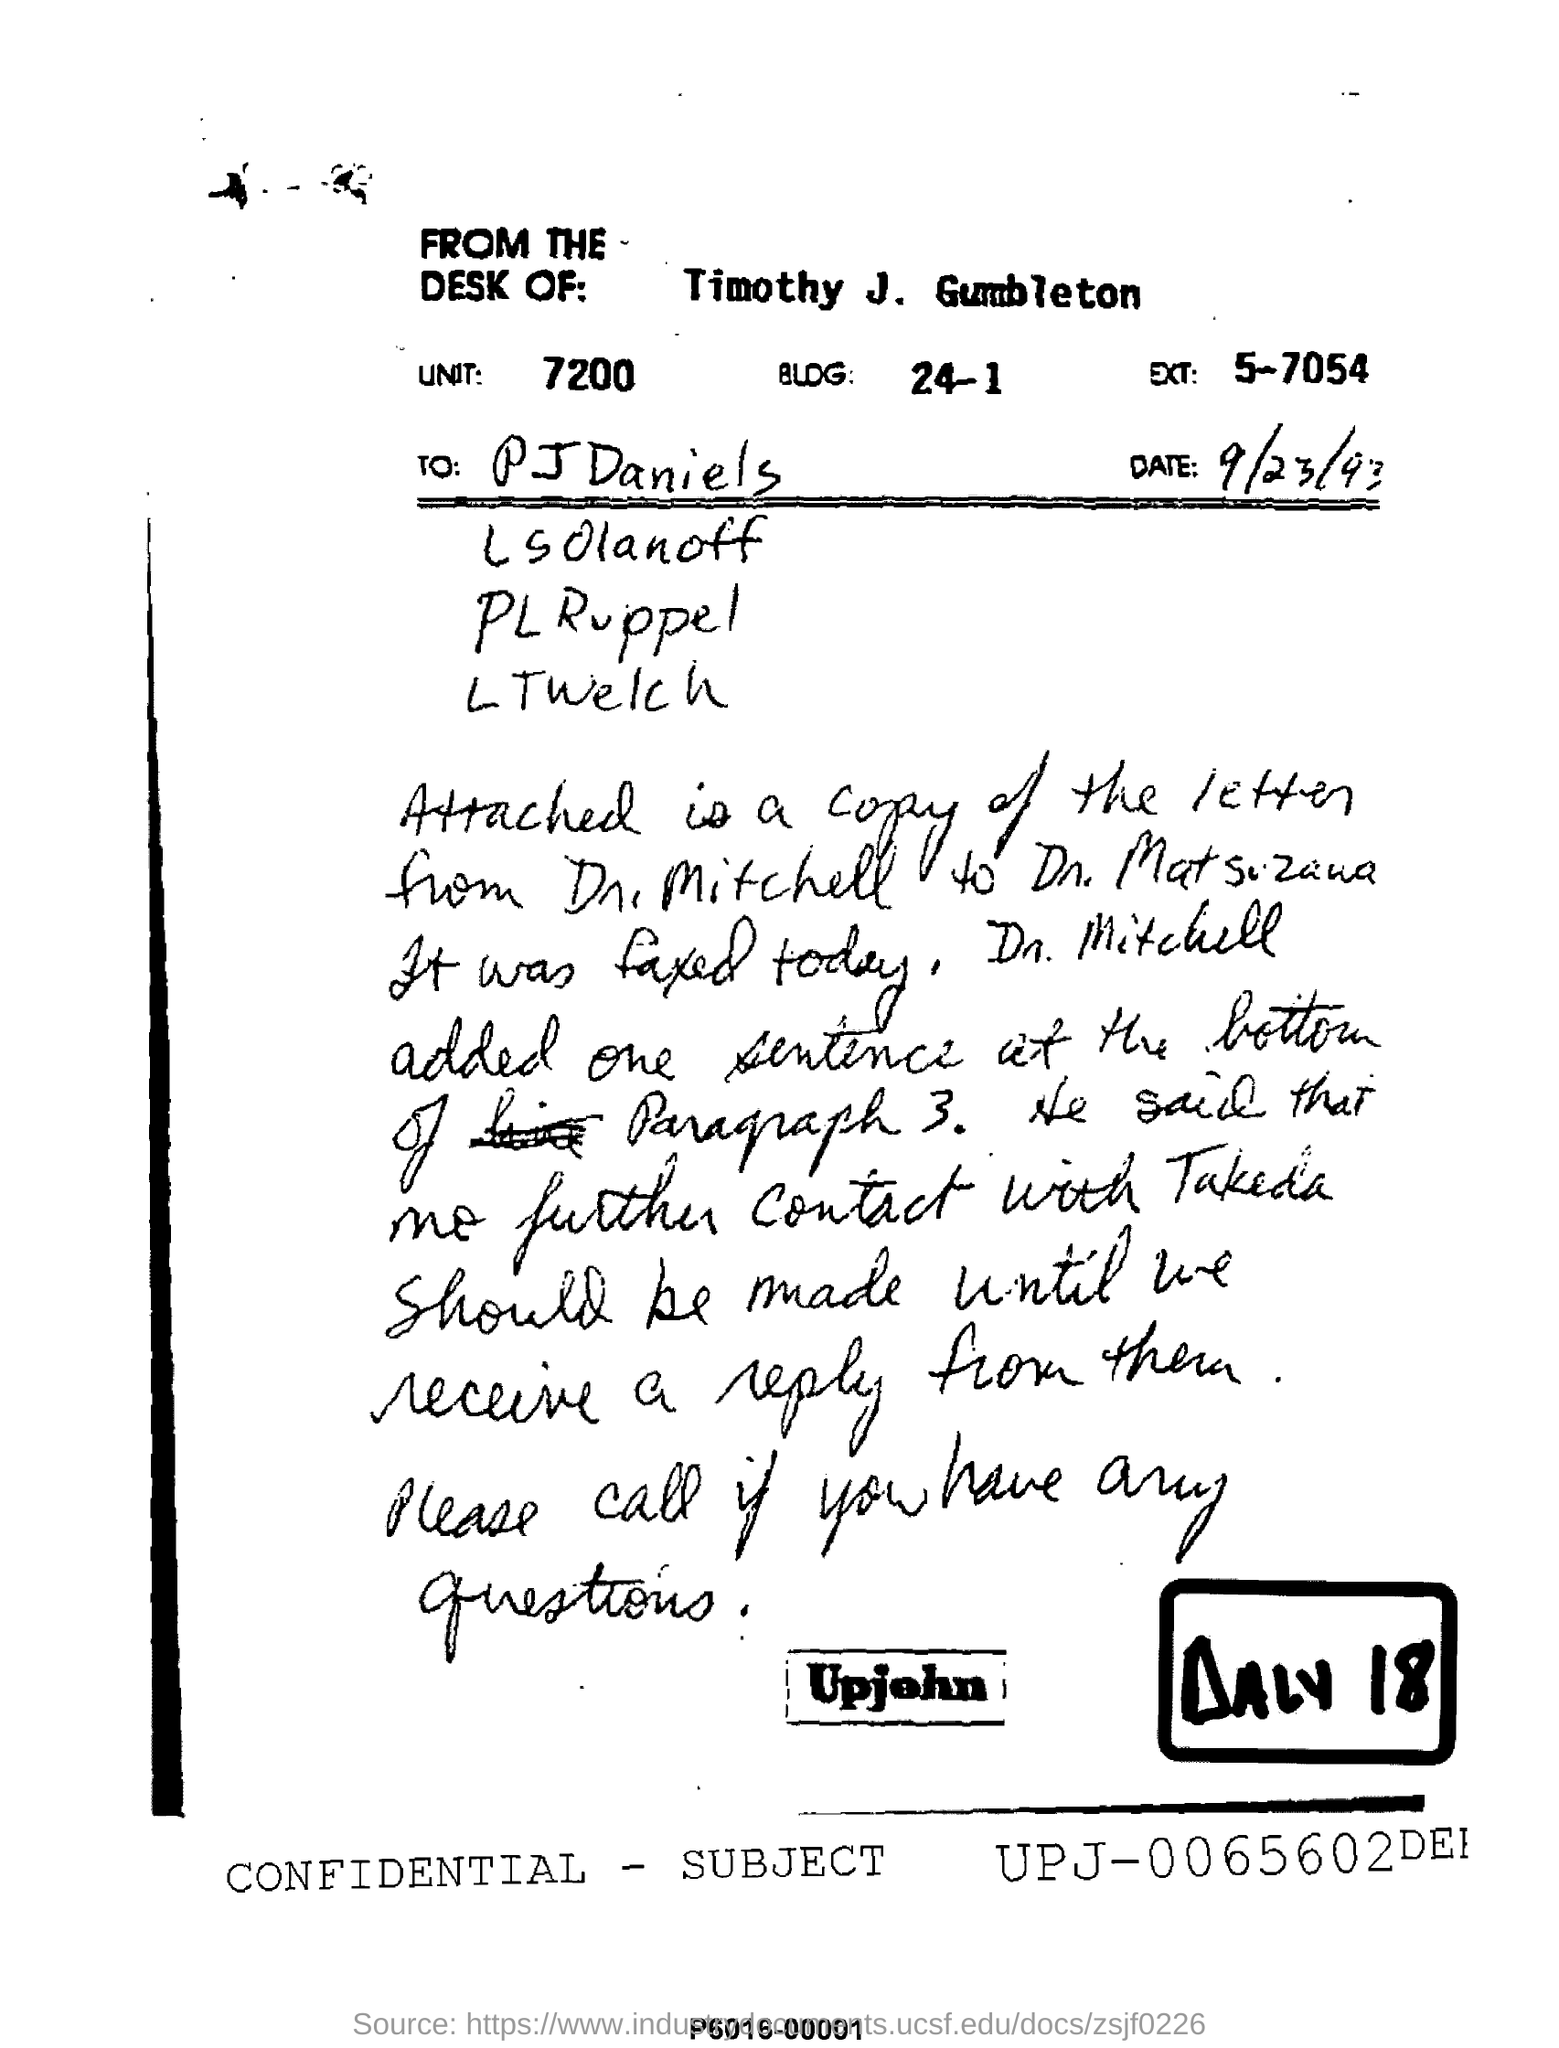What is the unit mentioned in the letter ?
Provide a succinct answer. 7200. What is the date mentioned
Your response must be concise. 9/23/93. Name of the first person in the To list?
Offer a very short reply. Pj daniels. From whose desk this letter is  written ?
Offer a terse response. Timothy j gumbleton. Whose letter's copy is attached?
Your response must be concise. DR. Mitchell. 